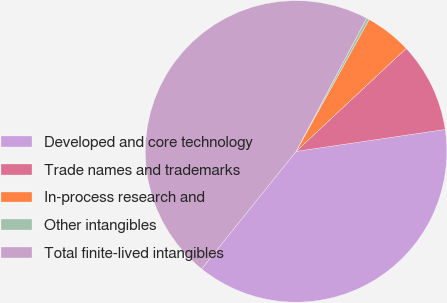Convert chart to OTSL. <chart><loc_0><loc_0><loc_500><loc_500><pie_chart><fcel>Developed and core technology<fcel>Trade names and trademarks<fcel>In-process research and<fcel>Other intangibles<fcel>Total finite-lived intangibles<nl><fcel>38.1%<fcel>9.64%<fcel>4.98%<fcel>0.31%<fcel>46.97%<nl></chart> 